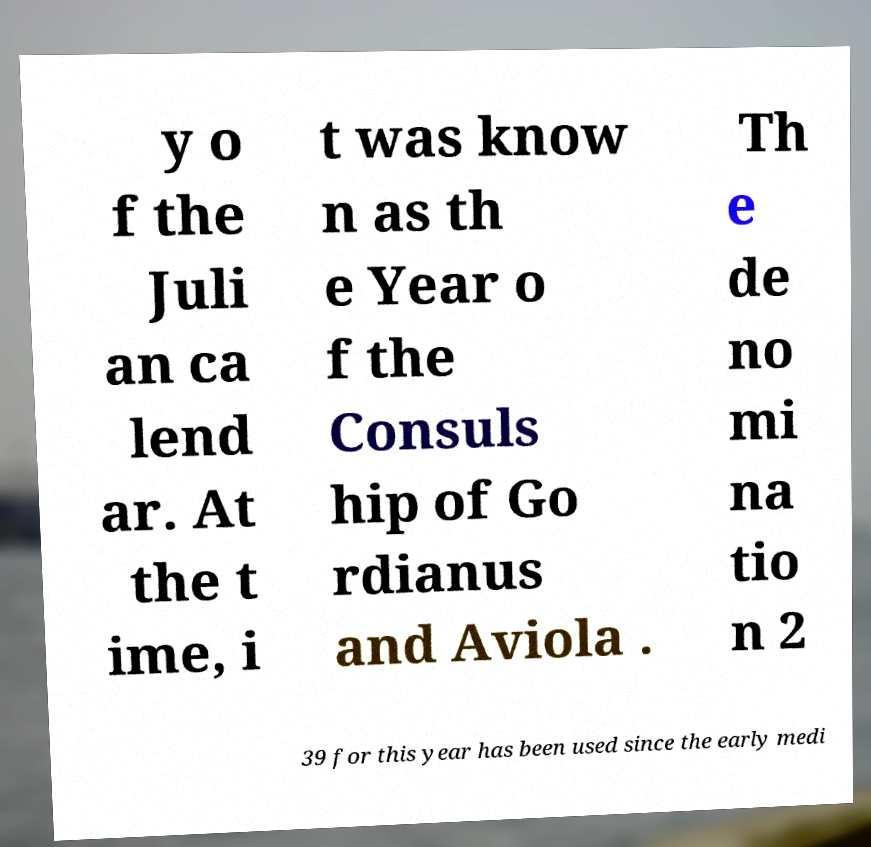There's text embedded in this image that I need extracted. Can you transcribe it verbatim? y o f the Juli an ca lend ar. At the t ime, i t was know n as th e Year o f the Consuls hip of Go rdianus and Aviola . Th e de no mi na tio n 2 39 for this year has been used since the early medi 